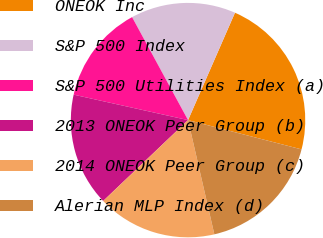Convert chart to OTSL. <chart><loc_0><loc_0><loc_500><loc_500><pie_chart><fcel>ONEOK Inc<fcel>S&P 500 Index<fcel>S&P 500 Utilities Index (a)<fcel>2013 ONEOK Peer Group (b)<fcel>2014 ONEOK Peer Group (c)<fcel>Alerian MLP Index (d)<nl><fcel>22.46%<fcel>14.48%<fcel>13.59%<fcel>15.6%<fcel>16.49%<fcel>17.38%<nl></chart> 